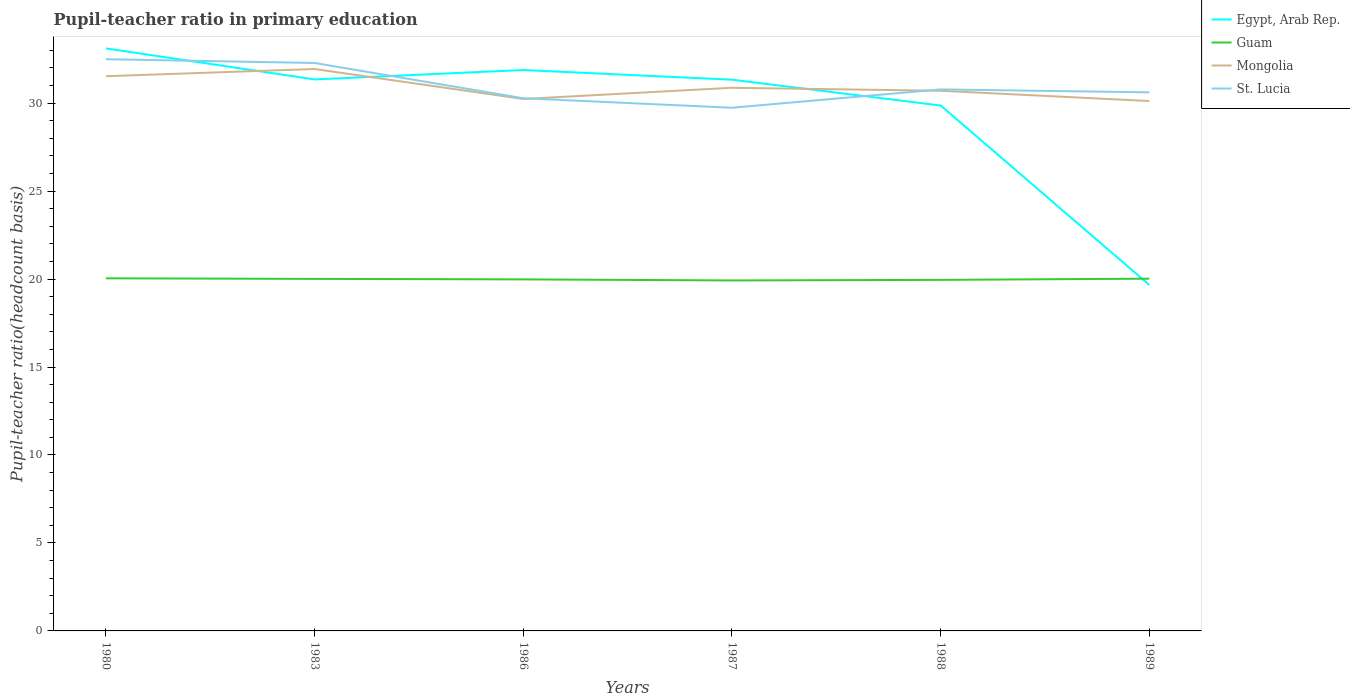How many different coloured lines are there?
Provide a short and direct response. 4. Does the line corresponding to Guam intersect with the line corresponding to St. Lucia?
Ensure brevity in your answer.  No. Across all years, what is the maximum pupil-teacher ratio in primary education in Egypt, Arab Rep.?
Your answer should be compact. 19.66. What is the total pupil-teacher ratio in primary education in Guam in the graph?
Ensure brevity in your answer.  0.09. What is the difference between the highest and the second highest pupil-teacher ratio in primary education in Guam?
Provide a succinct answer. 0.12. What is the difference between the highest and the lowest pupil-teacher ratio in primary education in Egypt, Arab Rep.?
Ensure brevity in your answer.  5. Is the pupil-teacher ratio in primary education in Mongolia strictly greater than the pupil-teacher ratio in primary education in Egypt, Arab Rep. over the years?
Your response must be concise. No. How many lines are there?
Provide a succinct answer. 4. How many years are there in the graph?
Provide a succinct answer. 6. What is the difference between two consecutive major ticks on the Y-axis?
Offer a very short reply. 5. Does the graph contain grids?
Provide a succinct answer. No. How many legend labels are there?
Offer a terse response. 4. How are the legend labels stacked?
Your answer should be very brief. Vertical. What is the title of the graph?
Provide a short and direct response. Pupil-teacher ratio in primary education. Does "Sint Maarten (Dutch part)" appear as one of the legend labels in the graph?
Provide a short and direct response. No. What is the label or title of the X-axis?
Make the answer very short. Years. What is the label or title of the Y-axis?
Provide a short and direct response. Pupil-teacher ratio(headcount basis). What is the Pupil-teacher ratio(headcount basis) of Egypt, Arab Rep. in 1980?
Your response must be concise. 33.11. What is the Pupil-teacher ratio(headcount basis) in Guam in 1980?
Offer a terse response. 20.04. What is the Pupil-teacher ratio(headcount basis) in Mongolia in 1980?
Give a very brief answer. 31.53. What is the Pupil-teacher ratio(headcount basis) in St. Lucia in 1980?
Your answer should be compact. 32.49. What is the Pupil-teacher ratio(headcount basis) in Egypt, Arab Rep. in 1983?
Provide a short and direct response. 31.35. What is the Pupil-teacher ratio(headcount basis) of Guam in 1983?
Keep it short and to the point. 20.01. What is the Pupil-teacher ratio(headcount basis) of Mongolia in 1983?
Keep it short and to the point. 31.94. What is the Pupil-teacher ratio(headcount basis) of St. Lucia in 1983?
Your response must be concise. 32.28. What is the Pupil-teacher ratio(headcount basis) in Egypt, Arab Rep. in 1986?
Offer a very short reply. 31.88. What is the Pupil-teacher ratio(headcount basis) of Guam in 1986?
Give a very brief answer. 19.98. What is the Pupil-teacher ratio(headcount basis) of Mongolia in 1986?
Your answer should be very brief. 30.23. What is the Pupil-teacher ratio(headcount basis) in St. Lucia in 1986?
Provide a short and direct response. 30.27. What is the Pupil-teacher ratio(headcount basis) in Egypt, Arab Rep. in 1987?
Keep it short and to the point. 31.33. What is the Pupil-teacher ratio(headcount basis) of Guam in 1987?
Your answer should be compact. 19.92. What is the Pupil-teacher ratio(headcount basis) of Mongolia in 1987?
Make the answer very short. 30.87. What is the Pupil-teacher ratio(headcount basis) of St. Lucia in 1987?
Ensure brevity in your answer.  29.74. What is the Pupil-teacher ratio(headcount basis) of Egypt, Arab Rep. in 1988?
Ensure brevity in your answer.  29.86. What is the Pupil-teacher ratio(headcount basis) in Guam in 1988?
Your answer should be very brief. 19.95. What is the Pupil-teacher ratio(headcount basis) in Mongolia in 1988?
Offer a very short reply. 30.7. What is the Pupil-teacher ratio(headcount basis) of St. Lucia in 1988?
Your answer should be compact. 30.78. What is the Pupil-teacher ratio(headcount basis) of Egypt, Arab Rep. in 1989?
Ensure brevity in your answer.  19.66. What is the Pupil-teacher ratio(headcount basis) of Guam in 1989?
Provide a short and direct response. 20.02. What is the Pupil-teacher ratio(headcount basis) of Mongolia in 1989?
Ensure brevity in your answer.  30.12. What is the Pupil-teacher ratio(headcount basis) of St. Lucia in 1989?
Offer a very short reply. 30.61. Across all years, what is the maximum Pupil-teacher ratio(headcount basis) in Egypt, Arab Rep.?
Keep it short and to the point. 33.11. Across all years, what is the maximum Pupil-teacher ratio(headcount basis) in Guam?
Ensure brevity in your answer.  20.04. Across all years, what is the maximum Pupil-teacher ratio(headcount basis) in Mongolia?
Provide a short and direct response. 31.94. Across all years, what is the maximum Pupil-teacher ratio(headcount basis) in St. Lucia?
Ensure brevity in your answer.  32.49. Across all years, what is the minimum Pupil-teacher ratio(headcount basis) in Egypt, Arab Rep.?
Your answer should be compact. 19.66. Across all years, what is the minimum Pupil-teacher ratio(headcount basis) of Guam?
Your answer should be compact. 19.92. Across all years, what is the minimum Pupil-teacher ratio(headcount basis) of Mongolia?
Your answer should be very brief. 30.12. Across all years, what is the minimum Pupil-teacher ratio(headcount basis) of St. Lucia?
Your answer should be compact. 29.74. What is the total Pupil-teacher ratio(headcount basis) in Egypt, Arab Rep. in the graph?
Give a very brief answer. 177.18. What is the total Pupil-teacher ratio(headcount basis) of Guam in the graph?
Make the answer very short. 119.92. What is the total Pupil-teacher ratio(headcount basis) in Mongolia in the graph?
Offer a terse response. 185.38. What is the total Pupil-teacher ratio(headcount basis) in St. Lucia in the graph?
Make the answer very short. 186.17. What is the difference between the Pupil-teacher ratio(headcount basis) of Egypt, Arab Rep. in 1980 and that in 1983?
Make the answer very short. 1.76. What is the difference between the Pupil-teacher ratio(headcount basis) in Guam in 1980 and that in 1983?
Provide a short and direct response. 0.03. What is the difference between the Pupil-teacher ratio(headcount basis) in Mongolia in 1980 and that in 1983?
Keep it short and to the point. -0.41. What is the difference between the Pupil-teacher ratio(headcount basis) in St. Lucia in 1980 and that in 1983?
Ensure brevity in your answer.  0.22. What is the difference between the Pupil-teacher ratio(headcount basis) of Egypt, Arab Rep. in 1980 and that in 1986?
Make the answer very short. 1.23. What is the difference between the Pupil-teacher ratio(headcount basis) in Guam in 1980 and that in 1986?
Your answer should be very brief. 0.06. What is the difference between the Pupil-teacher ratio(headcount basis) of Mongolia in 1980 and that in 1986?
Offer a very short reply. 1.29. What is the difference between the Pupil-teacher ratio(headcount basis) in St. Lucia in 1980 and that in 1986?
Ensure brevity in your answer.  2.22. What is the difference between the Pupil-teacher ratio(headcount basis) in Egypt, Arab Rep. in 1980 and that in 1987?
Make the answer very short. 1.78. What is the difference between the Pupil-teacher ratio(headcount basis) in Guam in 1980 and that in 1987?
Keep it short and to the point. 0.12. What is the difference between the Pupil-teacher ratio(headcount basis) in Mongolia in 1980 and that in 1987?
Your answer should be very brief. 0.66. What is the difference between the Pupil-teacher ratio(headcount basis) of St. Lucia in 1980 and that in 1987?
Provide a succinct answer. 2.76. What is the difference between the Pupil-teacher ratio(headcount basis) of Egypt, Arab Rep. in 1980 and that in 1988?
Your answer should be compact. 3.25. What is the difference between the Pupil-teacher ratio(headcount basis) of Guam in 1980 and that in 1988?
Your answer should be compact. 0.09. What is the difference between the Pupil-teacher ratio(headcount basis) in Mongolia in 1980 and that in 1988?
Ensure brevity in your answer.  0.83. What is the difference between the Pupil-teacher ratio(headcount basis) in St. Lucia in 1980 and that in 1988?
Offer a terse response. 1.72. What is the difference between the Pupil-teacher ratio(headcount basis) in Egypt, Arab Rep. in 1980 and that in 1989?
Ensure brevity in your answer.  13.45. What is the difference between the Pupil-teacher ratio(headcount basis) of Guam in 1980 and that in 1989?
Provide a short and direct response. 0.02. What is the difference between the Pupil-teacher ratio(headcount basis) of Mongolia in 1980 and that in 1989?
Offer a very short reply. 1.41. What is the difference between the Pupil-teacher ratio(headcount basis) of St. Lucia in 1980 and that in 1989?
Offer a very short reply. 1.88. What is the difference between the Pupil-teacher ratio(headcount basis) in Egypt, Arab Rep. in 1983 and that in 1986?
Your response must be concise. -0.53. What is the difference between the Pupil-teacher ratio(headcount basis) of Guam in 1983 and that in 1986?
Provide a short and direct response. 0.03. What is the difference between the Pupil-teacher ratio(headcount basis) of Mongolia in 1983 and that in 1986?
Offer a very short reply. 1.7. What is the difference between the Pupil-teacher ratio(headcount basis) of St. Lucia in 1983 and that in 1986?
Provide a short and direct response. 2.01. What is the difference between the Pupil-teacher ratio(headcount basis) of Egypt, Arab Rep. in 1983 and that in 1987?
Give a very brief answer. 0.02. What is the difference between the Pupil-teacher ratio(headcount basis) of Guam in 1983 and that in 1987?
Offer a very short reply. 0.09. What is the difference between the Pupil-teacher ratio(headcount basis) of Mongolia in 1983 and that in 1987?
Provide a short and direct response. 1.07. What is the difference between the Pupil-teacher ratio(headcount basis) in St. Lucia in 1983 and that in 1987?
Your answer should be compact. 2.54. What is the difference between the Pupil-teacher ratio(headcount basis) in Egypt, Arab Rep. in 1983 and that in 1988?
Keep it short and to the point. 1.49. What is the difference between the Pupil-teacher ratio(headcount basis) of Guam in 1983 and that in 1988?
Provide a short and direct response. 0.06. What is the difference between the Pupil-teacher ratio(headcount basis) in Mongolia in 1983 and that in 1988?
Ensure brevity in your answer.  1.24. What is the difference between the Pupil-teacher ratio(headcount basis) in St. Lucia in 1983 and that in 1988?
Keep it short and to the point. 1.5. What is the difference between the Pupil-teacher ratio(headcount basis) in Egypt, Arab Rep. in 1983 and that in 1989?
Your answer should be compact. 11.69. What is the difference between the Pupil-teacher ratio(headcount basis) in Guam in 1983 and that in 1989?
Offer a very short reply. -0.01. What is the difference between the Pupil-teacher ratio(headcount basis) in Mongolia in 1983 and that in 1989?
Keep it short and to the point. 1.82. What is the difference between the Pupil-teacher ratio(headcount basis) of St. Lucia in 1983 and that in 1989?
Your response must be concise. 1.67. What is the difference between the Pupil-teacher ratio(headcount basis) of Egypt, Arab Rep. in 1986 and that in 1987?
Offer a terse response. 0.55. What is the difference between the Pupil-teacher ratio(headcount basis) of Guam in 1986 and that in 1987?
Your response must be concise. 0.06. What is the difference between the Pupil-teacher ratio(headcount basis) of Mongolia in 1986 and that in 1987?
Offer a very short reply. -0.64. What is the difference between the Pupil-teacher ratio(headcount basis) of St. Lucia in 1986 and that in 1987?
Your answer should be compact. 0.54. What is the difference between the Pupil-teacher ratio(headcount basis) of Egypt, Arab Rep. in 1986 and that in 1988?
Provide a short and direct response. 2.02. What is the difference between the Pupil-teacher ratio(headcount basis) of Guam in 1986 and that in 1988?
Offer a terse response. 0.03. What is the difference between the Pupil-teacher ratio(headcount basis) in Mongolia in 1986 and that in 1988?
Provide a succinct answer. -0.47. What is the difference between the Pupil-teacher ratio(headcount basis) of St. Lucia in 1986 and that in 1988?
Provide a succinct answer. -0.5. What is the difference between the Pupil-teacher ratio(headcount basis) in Egypt, Arab Rep. in 1986 and that in 1989?
Your answer should be very brief. 12.22. What is the difference between the Pupil-teacher ratio(headcount basis) of Guam in 1986 and that in 1989?
Offer a very short reply. -0.04. What is the difference between the Pupil-teacher ratio(headcount basis) in Mongolia in 1986 and that in 1989?
Your answer should be very brief. 0.12. What is the difference between the Pupil-teacher ratio(headcount basis) of St. Lucia in 1986 and that in 1989?
Your answer should be compact. -0.34. What is the difference between the Pupil-teacher ratio(headcount basis) in Egypt, Arab Rep. in 1987 and that in 1988?
Offer a terse response. 1.47. What is the difference between the Pupil-teacher ratio(headcount basis) of Guam in 1987 and that in 1988?
Your answer should be very brief. -0.03. What is the difference between the Pupil-teacher ratio(headcount basis) in Mongolia in 1987 and that in 1988?
Provide a succinct answer. 0.17. What is the difference between the Pupil-teacher ratio(headcount basis) in St. Lucia in 1987 and that in 1988?
Make the answer very short. -1.04. What is the difference between the Pupil-teacher ratio(headcount basis) in Egypt, Arab Rep. in 1987 and that in 1989?
Your response must be concise. 11.67. What is the difference between the Pupil-teacher ratio(headcount basis) of Guam in 1987 and that in 1989?
Offer a very short reply. -0.1. What is the difference between the Pupil-teacher ratio(headcount basis) in Mongolia in 1987 and that in 1989?
Provide a succinct answer. 0.75. What is the difference between the Pupil-teacher ratio(headcount basis) in St. Lucia in 1987 and that in 1989?
Provide a succinct answer. -0.87. What is the difference between the Pupil-teacher ratio(headcount basis) in Egypt, Arab Rep. in 1988 and that in 1989?
Give a very brief answer. 10.2. What is the difference between the Pupil-teacher ratio(headcount basis) of Guam in 1988 and that in 1989?
Your answer should be very brief. -0.07. What is the difference between the Pupil-teacher ratio(headcount basis) of Mongolia in 1988 and that in 1989?
Offer a terse response. 0.58. What is the difference between the Pupil-teacher ratio(headcount basis) in St. Lucia in 1988 and that in 1989?
Provide a succinct answer. 0.17. What is the difference between the Pupil-teacher ratio(headcount basis) of Egypt, Arab Rep. in 1980 and the Pupil-teacher ratio(headcount basis) of Guam in 1983?
Ensure brevity in your answer.  13.1. What is the difference between the Pupil-teacher ratio(headcount basis) of Egypt, Arab Rep. in 1980 and the Pupil-teacher ratio(headcount basis) of Mongolia in 1983?
Make the answer very short. 1.17. What is the difference between the Pupil-teacher ratio(headcount basis) of Egypt, Arab Rep. in 1980 and the Pupil-teacher ratio(headcount basis) of St. Lucia in 1983?
Your response must be concise. 0.83. What is the difference between the Pupil-teacher ratio(headcount basis) in Guam in 1980 and the Pupil-teacher ratio(headcount basis) in Mongolia in 1983?
Your answer should be compact. -11.9. What is the difference between the Pupil-teacher ratio(headcount basis) of Guam in 1980 and the Pupil-teacher ratio(headcount basis) of St. Lucia in 1983?
Ensure brevity in your answer.  -12.24. What is the difference between the Pupil-teacher ratio(headcount basis) of Mongolia in 1980 and the Pupil-teacher ratio(headcount basis) of St. Lucia in 1983?
Provide a succinct answer. -0.75. What is the difference between the Pupil-teacher ratio(headcount basis) of Egypt, Arab Rep. in 1980 and the Pupil-teacher ratio(headcount basis) of Guam in 1986?
Ensure brevity in your answer.  13.13. What is the difference between the Pupil-teacher ratio(headcount basis) in Egypt, Arab Rep. in 1980 and the Pupil-teacher ratio(headcount basis) in Mongolia in 1986?
Give a very brief answer. 2.87. What is the difference between the Pupil-teacher ratio(headcount basis) in Egypt, Arab Rep. in 1980 and the Pupil-teacher ratio(headcount basis) in St. Lucia in 1986?
Ensure brevity in your answer.  2.83. What is the difference between the Pupil-teacher ratio(headcount basis) of Guam in 1980 and the Pupil-teacher ratio(headcount basis) of Mongolia in 1986?
Offer a very short reply. -10.19. What is the difference between the Pupil-teacher ratio(headcount basis) of Guam in 1980 and the Pupil-teacher ratio(headcount basis) of St. Lucia in 1986?
Give a very brief answer. -10.23. What is the difference between the Pupil-teacher ratio(headcount basis) of Mongolia in 1980 and the Pupil-teacher ratio(headcount basis) of St. Lucia in 1986?
Your answer should be very brief. 1.25. What is the difference between the Pupil-teacher ratio(headcount basis) of Egypt, Arab Rep. in 1980 and the Pupil-teacher ratio(headcount basis) of Guam in 1987?
Offer a terse response. 13.19. What is the difference between the Pupil-teacher ratio(headcount basis) of Egypt, Arab Rep. in 1980 and the Pupil-teacher ratio(headcount basis) of Mongolia in 1987?
Your answer should be very brief. 2.24. What is the difference between the Pupil-teacher ratio(headcount basis) of Egypt, Arab Rep. in 1980 and the Pupil-teacher ratio(headcount basis) of St. Lucia in 1987?
Ensure brevity in your answer.  3.37. What is the difference between the Pupil-teacher ratio(headcount basis) of Guam in 1980 and the Pupil-teacher ratio(headcount basis) of Mongolia in 1987?
Your response must be concise. -10.83. What is the difference between the Pupil-teacher ratio(headcount basis) in Guam in 1980 and the Pupil-teacher ratio(headcount basis) in St. Lucia in 1987?
Ensure brevity in your answer.  -9.69. What is the difference between the Pupil-teacher ratio(headcount basis) of Mongolia in 1980 and the Pupil-teacher ratio(headcount basis) of St. Lucia in 1987?
Make the answer very short. 1.79. What is the difference between the Pupil-teacher ratio(headcount basis) of Egypt, Arab Rep. in 1980 and the Pupil-teacher ratio(headcount basis) of Guam in 1988?
Provide a succinct answer. 13.16. What is the difference between the Pupil-teacher ratio(headcount basis) of Egypt, Arab Rep. in 1980 and the Pupil-teacher ratio(headcount basis) of Mongolia in 1988?
Your answer should be very brief. 2.41. What is the difference between the Pupil-teacher ratio(headcount basis) of Egypt, Arab Rep. in 1980 and the Pupil-teacher ratio(headcount basis) of St. Lucia in 1988?
Give a very brief answer. 2.33. What is the difference between the Pupil-teacher ratio(headcount basis) of Guam in 1980 and the Pupil-teacher ratio(headcount basis) of Mongolia in 1988?
Make the answer very short. -10.66. What is the difference between the Pupil-teacher ratio(headcount basis) of Guam in 1980 and the Pupil-teacher ratio(headcount basis) of St. Lucia in 1988?
Keep it short and to the point. -10.74. What is the difference between the Pupil-teacher ratio(headcount basis) in Mongolia in 1980 and the Pupil-teacher ratio(headcount basis) in St. Lucia in 1988?
Offer a very short reply. 0.75. What is the difference between the Pupil-teacher ratio(headcount basis) in Egypt, Arab Rep. in 1980 and the Pupil-teacher ratio(headcount basis) in Guam in 1989?
Make the answer very short. 13.09. What is the difference between the Pupil-teacher ratio(headcount basis) in Egypt, Arab Rep. in 1980 and the Pupil-teacher ratio(headcount basis) in Mongolia in 1989?
Your response must be concise. 2.99. What is the difference between the Pupil-teacher ratio(headcount basis) of Egypt, Arab Rep. in 1980 and the Pupil-teacher ratio(headcount basis) of St. Lucia in 1989?
Your answer should be very brief. 2.5. What is the difference between the Pupil-teacher ratio(headcount basis) in Guam in 1980 and the Pupil-teacher ratio(headcount basis) in Mongolia in 1989?
Provide a succinct answer. -10.08. What is the difference between the Pupil-teacher ratio(headcount basis) of Guam in 1980 and the Pupil-teacher ratio(headcount basis) of St. Lucia in 1989?
Keep it short and to the point. -10.57. What is the difference between the Pupil-teacher ratio(headcount basis) in Mongolia in 1980 and the Pupil-teacher ratio(headcount basis) in St. Lucia in 1989?
Your response must be concise. 0.92. What is the difference between the Pupil-teacher ratio(headcount basis) in Egypt, Arab Rep. in 1983 and the Pupil-teacher ratio(headcount basis) in Guam in 1986?
Your answer should be very brief. 11.37. What is the difference between the Pupil-teacher ratio(headcount basis) of Egypt, Arab Rep. in 1983 and the Pupil-teacher ratio(headcount basis) of Mongolia in 1986?
Make the answer very short. 1.11. What is the difference between the Pupil-teacher ratio(headcount basis) in Egypt, Arab Rep. in 1983 and the Pupil-teacher ratio(headcount basis) in St. Lucia in 1986?
Your answer should be compact. 1.07. What is the difference between the Pupil-teacher ratio(headcount basis) in Guam in 1983 and the Pupil-teacher ratio(headcount basis) in Mongolia in 1986?
Give a very brief answer. -10.23. What is the difference between the Pupil-teacher ratio(headcount basis) in Guam in 1983 and the Pupil-teacher ratio(headcount basis) in St. Lucia in 1986?
Your answer should be compact. -10.27. What is the difference between the Pupil-teacher ratio(headcount basis) in Mongolia in 1983 and the Pupil-teacher ratio(headcount basis) in St. Lucia in 1986?
Offer a terse response. 1.66. What is the difference between the Pupil-teacher ratio(headcount basis) in Egypt, Arab Rep. in 1983 and the Pupil-teacher ratio(headcount basis) in Guam in 1987?
Offer a very short reply. 11.42. What is the difference between the Pupil-teacher ratio(headcount basis) in Egypt, Arab Rep. in 1983 and the Pupil-teacher ratio(headcount basis) in Mongolia in 1987?
Provide a short and direct response. 0.47. What is the difference between the Pupil-teacher ratio(headcount basis) in Egypt, Arab Rep. in 1983 and the Pupil-teacher ratio(headcount basis) in St. Lucia in 1987?
Offer a very short reply. 1.61. What is the difference between the Pupil-teacher ratio(headcount basis) of Guam in 1983 and the Pupil-teacher ratio(headcount basis) of Mongolia in 1987?
Make the answer very short. -10.86. What is the difference between the Pupil-teacher ratio(headcount basis) of Guam in 1983 and the Pupil-teacher ratio(headcount basis) of St. Lucia in 1987?
Offer a terse response. -9.73. What is the difference between the Pupil-teacher ratio(headcount basis) in Mongolia in 1983 and the Pupil-teacher ratio(headcount basis) in St. Lucia in 1987?
Your response must be concise. 2.2. What is the difference between the Pupil-teacher ratio(headcount basis) in Egypt, Arab Rep. in 1983 and the Pupil-teacher ratio(headcount basis) in Guam in 1988?
Make the answer very short. 11.39. What is the difference between the Pupil-teacher ratio(headcount basis) in Egypt, Arab Rep. in 1983 and the Pupil-teacher ratio(headcount basis) in Mongolia in 1988?
Give a very brief answer. 0.64. What is the difference between the Pupil-teacher ratio(headcount basis) in Egypt, Arab Rep. in 1983 and the Pupil-teacher ratio(headcount basis) in St. Lucia in 1988?
Make the answer very short. 0.57. What is the difference between the Pupil-teacher ratio(headcount basis) in Guam in 1983 and the Pupil-teacher ratio(headcount basis) in Mongolia in 1988?
Your answer should be compact. -10.69. What is the difference between the Pupil-teacher ratio(headcount basis) in Guam in 1983 and the Pupil-teacher ratio(headcount basis) in St. Lucia in 1988?
Ensure brevity in your answer.  -10.77. What is the difference between the Pupil-teacher ratio(headcount basis) in Mongolia in 1983 and the Pupil-teacher ratio(headcount basis) in St. Lucia in 1988?
Your answer should be very brief. 1.16. What is the difference between the Pupil-teacher ratio(headcount basis) in Egypt, Arab Rep. in 1983 and the Pupil-teacher ratio(headcount basis) in Guam in 1989?
Offer a terse response. 11.32. What is the difference between the Pupil-teacher ratio(headcount basis) of Egypt, Arab Rep. in 1983 and the Pupil-teacher ratio(headcount basis) of Mongolia in 1989?
Give a very brief answer. 1.23. What is the difference between the Pupil-teacher ratio(headcount basis) in Egypt, Arab Rep. in 1983 and the Pupil-teacher ratio(headcount basis) in St. Lucia in 1989?
Make the answer very short. 0.74. What is the difference between the Pupil-teacher ratio(headcount basis) of Guam in 1983 and the Pupil-teacher ratio(headcount basis) of Mongolia in 1989?
Offer a very short reply. -10.11. What is the difference between the Pupil-teacher ratio(headcount basis) in Guam in 1983 and the Pupil-teacher ratio(headcount basis) in St. Lucia in 1989?
Your response must be concise. -10.6. What is the difference between the Pupil-teacher ratio(headcount basis) of Mongolia in 1983 and the Pupil-teacher ratio(headcount basis) of St. Lucia in 1989?
Offer a very short reply. 1.33. What is the difference between the Pupil-teacher ratio(headcount basis) in Egypt, Arab Rep. in 1986 and the Pupil-teacher ratio(headcount basis) in Guam in 1987?
Provide a short and direct response. 11.96. What is the difference between the Pupil-teacher ratio(headcount basis) in Egypt, Arab Rep. in 1986 and the Pupil-teacher ratio(headcount basis) in Mongolia in 1987?
Offer a terse response. 1.01. What is the difference between the Pupil-teacher ratio(headcount basis) in Egypt, Arab Rep. in 1986 and the Pupil-teacher ratio(headcount basis) in St. Lucia in 1987?
Your response must be concise. 2.14. What is the difference between the Pupil-teacher ratio(headcount basis) of Guam in 1986 and the Pupil-teacher ratio(headcount basis) of Mongolia in 1987?
Make the answer very short. -10.89. What is the difference between the Pupil-teacher ratio(headcount basis) in Guam in 1986 and the Pupil-teacher ratio(headcount basis) in St. Lucia in 1987?
Your response must be concise. -9.76. What is the difference between the Pupil-teacher ratio(headcount basis) in Mongolia in 1986 and the Pupil-teacher ratio(headcount basis) in St. Lucia in 1987?
Give a very brief answer. 0.5. What is the difference between the Pupil-teacher ratio(headcount basis) of Egypt, Arab Rep. in 1986 and the Pupil-teacher ratio(headcount basis) of Guam in 1988?
Your answer should be compact. 11.93. What is the difference between the Pupil-teacher ratio(headcount basis) of Egypt, Arab Rep. in 1986 and the Pupil-teacher ratio(headcount basis) of Mongolia in 1988?
Offer a very short reply. 1.18. What is the difference between the Pupil-teacher ratio(headcount basis) of Egypt, Arab Rep. in 1986 and the Pupil-teacher ratio(headcount basis) of St. Lucia in 1988?
Provide a succinct answer. 1.1. What is the difference between the Pupil-teacher ratio(headcount basis) of Guam in 1986 and the Pupil-teacher ratio(headcount basis) of Mongolia in 1988?
Make the answer very short. -10.72. What is the difference between the Pupil-teacher ratio(headcount basis) of Guam in 1986 and the Pupil-teacher ratio(headcount basis) of St. Lucia in 1988?
Your answer should be compact. -10.8. What is the difference between the Pupil-teacher ratio(headcount basis) in Mongolia in 1986 and the Pupil-teacher ratio(headcount basis) in St. Lucia in 1988?
Give a very brief answer. -0.54. What is the difference between the Pupil-teacher ratio(headcount basis) in Egypt, Arab Rep. in 1986 and the Pupil-teacher ratio(headcount basis) in Guam in 1989?
Ensure brevity in your answer.  11.86. What is the difference between the Pupil-teacher ratio(headcount basis) in Egypt, Arab Rep. in 1986 and the Pupil-teacher ratio(headcount basis) in Mongolia in 1989?
Your answer should be compact. 1.76. What is the difference between the Pupil-teacher ratio(headcount basis) of Egypt, Arab Rep. in 1986 and the Pupil-teacher ratio(headcount basis) of St. Lucia in 1989?
Provide a short and direct response. 1.27. What is the difference between the Pupil-teacher ratio(headcount basis) of Guam in 1986 and the Pupil-teacher ratio(headcount basis) of Mongolia in 1989?
Provide a succinct answer. -10.14. What is the difference between the Pupil-teacher ratio(headcount basis) in Guam in 1986 and the Pupil-teacher ratio(headcount basis) in St. Lucia in 1989?
Keep it short and to the point. -10.63. What is the difference between the Pupil-teacher ratio(headcount basis) in Mongolia in 1986 and the Pupil-teacher ratio(headcount basis) in St. Lucia in 1989?
Provide a short and direct response. -0.38. What is the difference between the Pupil-teacher ratio(headcount basis) in Egypt, Arab Rep. in 1987 and the Pupil-teacher ratio(headcount basis) in Guam in 1988?
Your answer should be compact. 11.38. What is the difference between the Pupil-teacher ratio(headcount basis) in Egypt, Arab Rep. in 1987 and the Pupil-teacher ratio(headcount basis) in Mongolia in 1988?
Provide a short and direct response. 0.63. What is the difference between the Pupil-teacher ratio(headcount basis) of Egypt, Arab Rep. in 1987 and the Pupil-teacher ratio(headcount basis) of St. Lucia in 1988?
Give a very brief answer. 0.55. What is the difference between the Pupil-teacher ratio(headcount basis) in Guam in 1987 and the Pupil-teacher ratio(headcount basis) in Mongolia in 1988?
Give a very brief answer. -10.78. What is the difference between the Pupil-teacher ratio(headcount basis) of Guam in 1987 and the Pupil-teacher ratio(headcount basis) of St. Lucia in 1988?
Make the answer very short. -10.86. What is the difference between the Pupil-teacher ratio(headcount basis) in Mongolia in 1987 and the Pupil-teacher ratio(headcount basis) in St. Lucia in 1988?
Give a very brief answer. 0.09. What is the difference between the Pupil-teacher ratio(headcount basis) of Egypt, Arab Rep. in 1987 and the Pupil-teacher ratio(headcount basis) of Guam in 1989?
Give a very brief answer. 11.31. What is the difference between the Pupil-teacher ratio(headcount basis) of Egypt, Arab Rep. in 1987 and the Pupil-teacher ratio(headcount basis) of Mongolia in 1989?
Give a very brief answer. 1.21. What is the difference between the Pupil-teacher ratio(headcount basis) in Egypt, Arab Rep. in 1987 and the Pupil-teacher ratio(headcount basis) in St. Lucia in 1989?
Your answer should be very brief. 0.72. What is the difference between the Pupil-teacher ratio(headcount basis) of Guam in 1987 and the Pupil-teacher ratio(headcount basis) of Mongolia in 1989?
Offer a terse response. -10.2. What is the difference between the Pupil-teacher ratio(headcount basis) of Guam in 1987 and the Pupil-teacher ratio(headcount basis) of St. Lucia in 1989?
Provide a succinct answer. -10.69. What is the difference between the Pupil-teacher ratio(headcount basis) of Mongolia in 1987 and the Pupil-teacher ratio(headcount basis) of St. Lucia in 1989?
Your response must be concise. 0.26. What is the difference between the Pupil-teacher ratio(headcount basis) in Egypt, Arab Rep. in 1988 and the Pupil-teacher ratio(headcount basis) in Guam in 1989?
Your answer should be compact. 9.84. What is the difference between the Pupil-teacher ratio(headcount basis) in Egypt, Arab Rep. in 1988 and the Pupil-teacher ratio(headcount basis) in Mongolia in 1989?
Offer a terse response. -0.26. What is the difference between the Pupil-teacher ratio(headcount basis) in Egypt, Arab Rep. in 1988 and the Pupil-teacher ratio(headcount basis) in St. Lucia in 1989?
Your answer should be compact. -0.75. What is the difference between the Pupil-teacher ratio(headcount basis) of Guam in 1988 and the Pupil-teacher ratio(headcount basis) of Mongolia in 1989?
Your answer should be compact. -10.16. What is the difference between the Pupil-teacher ratio(headcount basis) in Guam in 1988 and the Pupil-teacher ratio(headcount basis) in St. Lucia in 1989?
Keep it short and to the point. -10.66. What is the difference between the Pupil-teacher ratio(headcount basis) of Mongolia in 1988 and the Pupil-teacher ratio(headcount basis) of St. Lucia in 1989?
Provide a succinct answer. 0.09. What is the average Pupil-teacher ratio(headcount basis) in Egypt, Arab Rep. per year?
Ensure brevity in your answer.  29.53. What is the average Pupil-teacher ratio(headcount basis) in Guam per year?
Your response must be concise. 19.99. What is the average Pupil-teacher ratio(headcount basis) in Mongolia per year?
Keep it short and to the point. 30.9. What is the average Pupil-teacher ratio(headcount basis) in St. Lucia per year?
Your answer should be very brief. 31.03. In the year 1980, what is the difference between the Pupil-teacher ratio(headcount basis) of Egypt, Arab Rep. and Pupil-teacher ratio(headcount basis) of Guam?
Your answer should be very brief. 13.07. In the year 1980, what is the difference between the Pupil-teacher ratio(headcount basis) of Egypt, Arab Rep. and Pupil-teacher ratio(headcount basis) of Mongolia?
Make the answer very short. 1.58. In the year 1980, what is the difference between the Pupil-teacher ratio(headcount basis) of Egypt, Arab Rep. and Pupil-teacher ratio(headcount basis) of St. Lucia?
Ensure brevity in your answer.  0.61. In the year 1980, what is the difference between the Pupil-teacher ratio(headcount basis) of Guam and Pupil-teacher ratio(headcount basis) of Mongolia?
Offer a very short reply. -11.49. In the year 1980, what is the difference between the Pupil-teacher ratio(headcount basis) in Guam and Pupil-teacher ratio(headcount basis) in St. Lucia?
Provide a short and direct response. -12.45. In the year 1980, what is the difference between the Pupil-teacher ratio(headcount basis) in Mongolia and Pupil-teacher ratio(headcount basis) in St. Lucia?
Offer a very short reply. -0.97. In the year 1983, what is the difference between the Pupil-teacher ratio(headcount basis) in Egypt, Arab Rep. and Pupil-teacher ratio(headcount basis) in Guam?
Offer a very short reply. 11.34. In the year 1983, what is the difference between the Pupil-teacher ratio(headcount basis) in Egypt, Arab Rep. and Pupil-teacher ratio(headcount basis) in Mongolia?
Your answer should be very brief. -0.59. In the year 1983, what is the difference between the Pupil-teacher ratio(headcount basis) in Egypt, Arab Rep. and Pupil-teacher ratio(headcount basis) in St. Lucia?
Offer a very short reply. -0.93. In the year 1983, what is the difference between the Pupil-teacher ratio(headcount basis) of Guam and Pupil-teacher ratio(headcount basis) of Mongolia?
Ensure brevity in your answer.  -11.93. In the year 1983, what is the difference between the Pupil-teacher ratio(headcount basis) in Guam and Pupil-teacher ratio(headcount basis) in St. Lucia?
Your answer should be very brief. -12.27. In the year 1983, what is the difference between the Pupil-teacher ratio(headcount basis) of Mongolia and Pupil-teacher ratio(headcount basis) of St. Lucia?
Give a very brief answer. -0.34. In the year 1986, what is the difference between the Pupil-teacher ratio(headcount basis) of Egypt, Arab Rep. and Pupil-teacher ratio(headcount basis) of Guam?
Your response must be concise. 11.9. In the year 1986, what is the difference between the Pupil-teacher ratio(headcount basis) of Egypt, Arab Rep. and Pupil-teacher ratio(headcount basis) of Mongolia?
Keep it short and to the point. 1.65. In the year 1986, what is the difference between the Pupil-teacher ratio(headcount basis) of Egypt, Arab Rep. and Pupil-teacher ratio(headcount basis) of St. Lucia?
Your answer should be very brief. 1.61. In the year 1986, what is the difference between the Pupil-teacher ratio(headcount basis) in Guam and Pupil-teacher ratio(headcount basis) in Mongolia?
Make the answer very short. -10.25. In the year 1986, what is the difference between the Pupil-teacher ratio(headcount basis) in Guam and Pupil-teacher ratio(headcount basis) in St. Lucia?
Offer a very short reply. -10.29. In the year 1986, what is the difference between the Pupil-teacher ratio(headcount basis) of Mongolia and Pupil-teacher ratio(headcount basis) of St. Lucia?
Your answer should be very brief. -0.04. In the year 1987, what is the difference between the Pupil-teacher ratio(headcount basis) in Egypt, Arab Rep. and Pupil-teacher ratio(headcount basis) in Guam?
Provide a short and direct response. 11.41. In the year 1987, what is the difference between the Pupil-teacher ratio(headcount basis) of Egypt, Arab Rep. and Pupil-teacher ratio(headcount basis) of Mongolia?
Your answer should be very brief. 0.46. In the year 1987, what is the difference between the Pupil-teacher ratio(headcount basis) of Egypt, Arab Rep. and Pupil-teacher ratio(headcount basis) of St. Lucia?
Make the answer very short. 1.59. In the year 1987, what is the difference between the Pupil-teacher ratio(headcount basis) in Guam and Pupil-teacher ratio(headcount basis) in Mongolia?
Your response must be concise. -10.95. In the year 1987, what is the difference between the Pupil-teacher ratio(headcount basis) of Guam and Pupil-teacher ratio(headcount basis) of St. Lucia?
Provide a short and direct response. -9.81. In the year 1987, what is the difference between the Pupil-teacher ratio(headcount basis) of Mongolia and Pupil-teacher ratio(headcount basis) of St. Lucia?
Give a very brief answer. 1.13. In the year 1988, what is the difference between the Pupil-teacher ratio(headcount basis) in Egypt, Arab Rep. and Pupil-teacher ratio(headcount basis) in Guam?
Offer a terse response. 9.91. In the year 1988, what is the difference between the Pupil-teacher ratio(headcount basis) in Egypt, Arab Rep. and Pupil-teacher ratio(headcount basis) in Mongolia?
Ensure brevity in your answer.  -0.84. In the year 1988, what is the difference between the Pupil-teacher ratio(headcount basis) of Egypt, Arab Rep. and Pupil-teacher ratio(headcount basis) of St. Lucia?
Your answer should be compact. -0.92. In the year 1988, what is the difference between the Pupil-teacher ratio(headcount basis) of Guam and Pupil-teacher ratio(headcount basis) of Mongolia?
Provide a short and direct response. -10.75. In the year 1988, what is the difference between the Pupil-teacher ratio(headcount basis) of Guam and Pupil-teacher ratio(headcount basis) of St. Lucia?
Your answer should be compact. -10.83. In the year 1988, what is the difference between the Pupil-teacher ratio(headcount basis) in Mongolia and Pupil-teacher ratio(headcount basis) in St. Lucia?
Provide a succinct answer. -0.08. In the year 1989, what is the difference between the Pupil-teacher ratio(headcount basis) in Egypt, Arab Rep. and Pupil-teacher ratio(headcount basis) in Guam?
Your answer should be compact. -0.36. In the year 1989, what is the difference between the Pupil-teacher ratio(headcount basis) of Egypt, Arab Rep. and Pupil-teacher ratio(headcount basis) of Mongolia?
Make the answer very short. -10.46. In the year 1989, what is the difference between the Pupil-teacher ratio(headcount basis) in Egypt, Arab Rep. and Pupil-teacher ratio(headcount basis) in St. Lucia?
Your answer should be compact. -10.95. In the year 1989, what is the difference between the Pupil-teacher ratio(headcount basis) in Guam and Pupil-teacher ratio(headcount basis) in Mongolia?
Your response must be concise. -10.1. In the year 1989, what is the difference between the Pupil-teacher ratio(headcount basis) in Guam and Pupil-teacher ratio(headcount basis) in St. Lucia?
Give a very brief answer. -10.59. In the year 1989, what is the difference between the Pupil-teacher ratio(headcount basis) in Mongolia and Pupil-teacher ratio(headcount basis) in St. Lucia?
Give a very brief answer. -0.49. What is the ratio of the Pupil-teacher ratio(headcount basis) in Egypt, Arab Rep. in 1980 to that in 1983?
Your answer should be very brief. 1.06. What is the ratio of the Pupil-teacher ratio(headcount basis) of Mongolia in 1980 to that in 1983?
Your response must be concise. 0.99. What is the ratio of the Pupil-teacher ratio(headcount basis) of St. Lucia in 1980 to that in 1983?
Make the answer very short. 1.01. What is the ratio of the Pupil-teacher ratio(headcount basis) of Egypt, Arab Rep. in 1980 to that in 1986?
Ensure brevity in your answer.  1.04. What is the ratio of the Pupil-teacher ratio(headcount basis) of Mongolia in 1980 to that in 1986?
Make the answer very short. 1.04. What is the ratio of the Pupil-teacher ratio(headcount basis) in St. Lucia in 1980 to that in 1986?
Offer a very short reply. 1.07. What is the ratio of the Pupil-teacher ratio(headcount basis) of Egypt, Arab Rep. in 1980 to that in 1987?
Offer a very short reply. 1.06. What is the ratio of the Pupil-teacher ratio(headcount basis) of Mongolia in 1980 to that in 1987?
Your response must be concise. 1.02. What is the ratio of the Pupil-teacher ratio(headcount basis) of St. Lucia in 1980 to that in 1987?
Offer a very short reply. 1.09. What is the ratio of the Pupil-teacher ratio(headcount basis) in Egypt, Arab Rep. in 1980 to that in 1988?
Offer a terse response. 1.11. What is the ratio of the Pupil-teacher ratio(headcount basis) of Guam in 1980 to that in 1988?
Provide a short and direct response. 1. What is the ratio of the Pupil-teacher ratio(headcount basis) in Mongolia in 1980 to that in 1988?
Provide a succinct answer. 1.03. What is the ratio of the Pupil-teacher ratio(headcount basis) in St. Lucia in 1980 to that in 1988?
Give a very brief answer. 1.06. What is the ratio of the Pupil-teacher ratio(headcount basis) of Egypt, Arab Rep. in 1980 to that in 1989?
Keep it short and to the point. 1.68. What is the ratio of the Pupil-teacher ratio(headcount basis) of Mongolia in 1980 to that in 1989?
Provide a succinct answer. 1.05. What is the ratio of the Pupil-teacher ratio(headcount basis) of St. Lucia in 1980 to that in 1989?
Your response must be concise. 1.06. What is the ratio of the Pupil-teacher ratio(headcount basis) of Egypt, Arab Rep. in 1983 to that in 1986?
Provide a succinct answer. 0.98. What is the ratio of the Pupil-teacher ratio(headcount basis) of Guam in 1983 to that in 1986?
Offer a terse response. 1. What is the ratio of the Pupil-teacher ratio(headcount basis) in Mongolia in 1983 to that in 1986?
Keep it short and to the point. 1.06. What is the ratio of the Pupil-teacher ratio(headcount basis) in St. Lucia in 1983 to that in 1986?
Provide a succinct answer. 1.07. What is the ratio of the Pupil-teacher ratio(headcount basis) in Egypt, Arab Rep. in 1983 to that in 1987?
Provide a succinct answer. 1. What is the ratio of the Pupil-teacher ratio(headcount basis) in Mongolia in 1983 to that in 1987?
Keep it short and to the point. 1.03. What is the ratio of the Pupil-teacher ratio(headcount basis) in St. Lucia in 1983 to that in 1987?
Your response must be concise. 1.09. What is the ratio of the Pupil-teacher ratio(headcount basis) of Egypt, Arab Rep. in 1983 to that in 1988?
Provide a succinct answer. 1.05. What is the ratio of the Pupil-teacher ratio(headcount basis) in Guam in 1983 to that in 1988?
Your answer should be compact. 1. What is the ratio of the Pupil-teacher ratio(headcount basis) in Mongolia in 1983 to that in 1988?
Your answer should be compact. 1.04. What is the ratio of the Pupil-teacher ratio(headcount basis) in St. Lucia in 1983 to that in 1988?
Offer a terse response. 1.05. What is the ratio of the Pupil-teacher ratio(headcount basis) in Egypt, Arab Rep. in 1983 to that in 1989?
Give a very brief answer. 1.59. What is the ratio of the Pupil-teacher ratio(headcount basis) in Mongolia in 1983 to that in 1989?
Your response must be concise. 1.06. What is the ratio of the Pupil-teacher ratio(headcount basis) of St. Lucia in 1983 to that in 1989?
Keep it short and to the point. 1.05. What is the ratio of the Pupil-teacher ratio(headcount basis) of Egypt, Arab Rep. in 1986 to that in 1987?
Provide a succinct answer. 1.02. What is the ratio of the Pupil-teacher ratio(headcount basis) of Mongolia in 1986 to that in 1987?
Your answer should be compact. 0.98. What is the ratio of the Pupil-teacher ratio(headcount basis) of St. Lucia in 1986 to that in 1987?
Your response must be concise. 1.02. What is the ratio of the Pupil-teacher ratio(headcount basis) of Egypt, Arab Rep. in 1986 to that in 1988?
Ensure brevity in your answer.  1.07. What is the ratio of the Pupil-teacher ratio(headcount basis) of Guam in 1986 to that in 1988?
Provide a succinct answer. 1. What is the ratio of the Pupil-teacher ratio(headcount basis) in St. Lucia in 1986 to that in 1988?
Give a very brief answer. 0.98. What is the ratio of the Pupil-teacher ratio(headcount basis) of Egypt, Arab Rep. in 1986 to that in 1989?
Provide a short and direct response. 1.62. What is the ratio of the Pupil-teacher ratio(headcount basis) of Guam in 1986 to that in 1989?
Keep it short and to the point. 1. What is the ratio of the Pupil-teacher ratio(headcount basis) in Egypt, Arab Rep. in 1987 to that in 1988?
Your response must be concise. 1.05. What is the ratio of the Pupil-teacher ratio(headcount basis) in Mongolia in 1987 to that in 1988?
Provide a short and direct response. 1.01. What is the ratio of the Pupil-teacher ratio(headcount basis) of St. Lucia in 1987 to that in 1988?
Provide a short and direct response. 0.97. What is the ratio of the Pupil-teacher ratio(headcount basis) in Egypt, Arab Rep. in 1987 to that in 1989?
Provide a succinct answer. 1.59. What is the ratio of the Pupil-teacher ratio(headcount basis) of Mongolia in 1987 to that in 1989?
Provide a short and direct response. 1.02. What is the ratio of the Pupil-teacher ratio(headcount basis) in St. Lucia in 1987 to that in 1989?
Your response must be concise. 0.97. What is the ratio of the Pupil-teacher ratio(headcount basis) of Egypt, Arab Rep. in 1988 to that in 1989?
Your response must be concise. 1.52. What is the ratio of the Pupil-teacher ratio(headcount basis) in Guam in 1988 to that in 1989?
Your response must be concise. 1. What is the ratio of the Pupil-teacher ratio(headcount basis) of Mongolia in 1988 to that in 1989?
Your answer should be compact. 1.02. What is the ratio of the Pupil-teacher ratio(headcount basis) of St. Lucia in 1988 to that in 1989?
Keep it short and to the point. 1.01. What is the difference between the highest and the second highest Pupil-teacher ratio(headcount basis) in Egypt, Arab Rep.?
Offer a terse response. 1.23. What is the difference between the highest and the second highest Pupil-teacher ratio(headcount basis) in Guam?
Ensure brevity in your answer.  0.02. What is the difference between the highest and the second highest Pupil-teacher ratio(headcount basis) of Mongolia?
Give a very brief answer. 0.41. What is the difference between the highest and the second highest Pupil-teacher ratio(headcount basis) in St. Lucia?
Make the answer very short. 0.22. What is the difference between the highest and the lowest Pupil-teacher ratio(headcount basis) in Egypt, Arab Rep.?
Ensure brevity in your answer.  13.45. What is the difference between the highest and the lowest Pupil-teacher ratio(headcount basis) of Guam?
Offer a very short reply. 0.12. What is the difference between the highest and the lowest Pupil-teacher ratio(headcount basis) of Mongolia?
Offer a terse response. 1.82. What is the difference between the highest and the lowest Pupil-teacher ratio(headcount basis) in St. Lucia?
Keep it short and to the point. 2.76. 